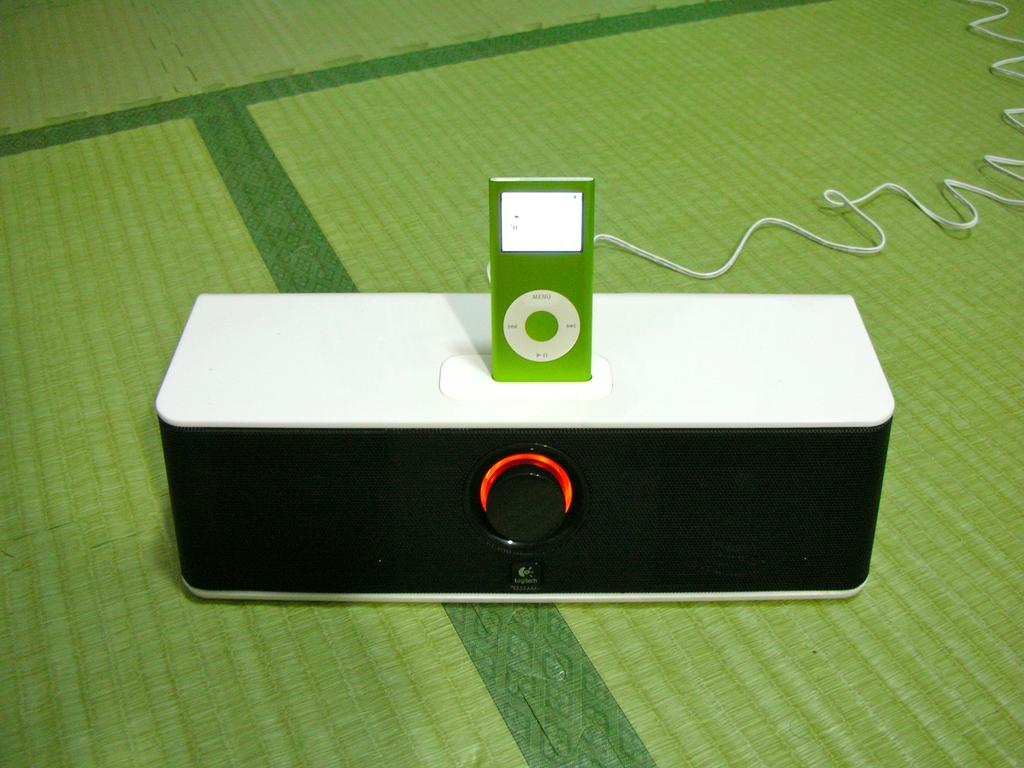What electronic device is visible in the image? There is a bluetooth speaker in the image. What is placed on top of the bluetooth speaker? An iPod is present on the bluetooth speaker. What type of wire can be seen in the image? There is a white wire in the image. On what surface is the wire resting? The wire is on a green surface. What is the tax rate for the spark generated by the cord in the image? There is no spark or cord present in the image, and therefore no tax rate can be determined. 